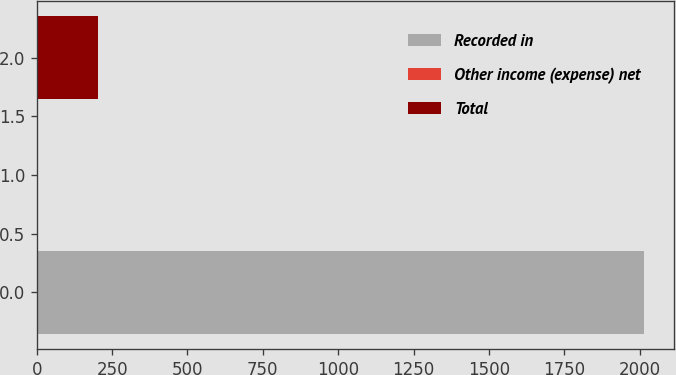<chart> <loc_0><loc_0><loc_500><loc_500><bar_chart><fcel>Recorded in<fcel>Other income (expense) net<fcel>Total<nl><fcel>2013<fcel>3<fcel>204<nl></chart> 